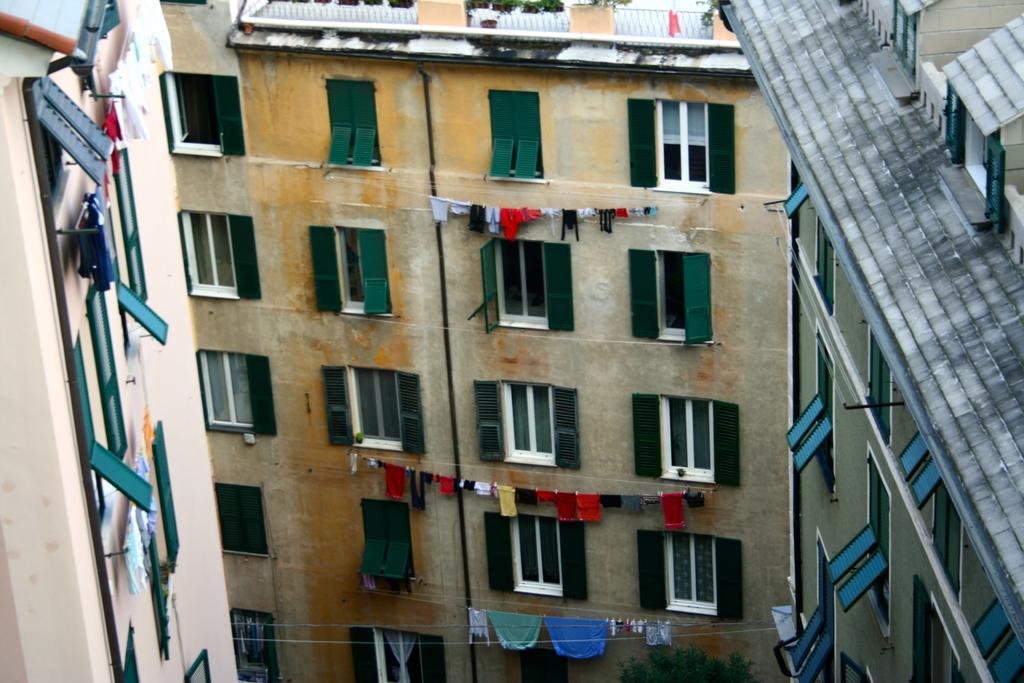How would you summarize this image in a sentence or two? In this picture there are buildings in the image and there are windows on the building, there are clothes on the ropes in the image. 